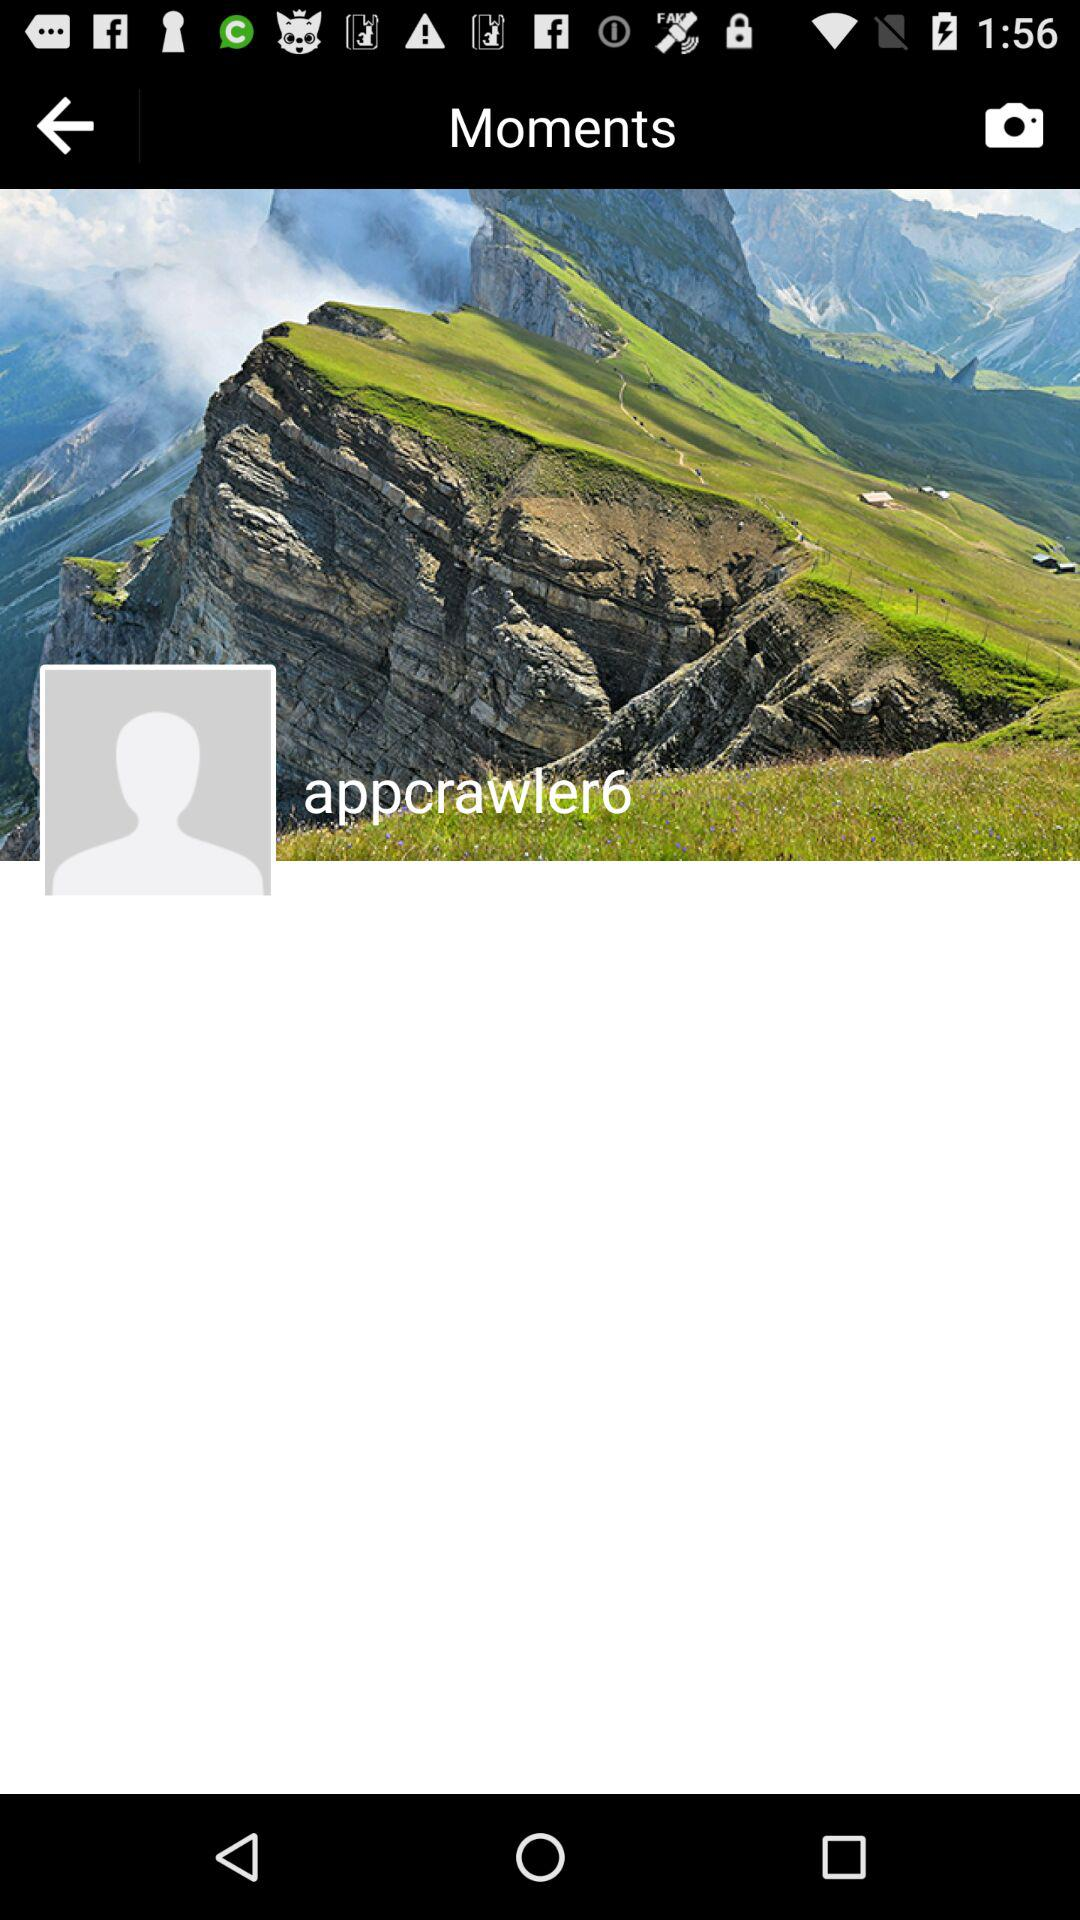What is the username? The username is "appcrawler6". 